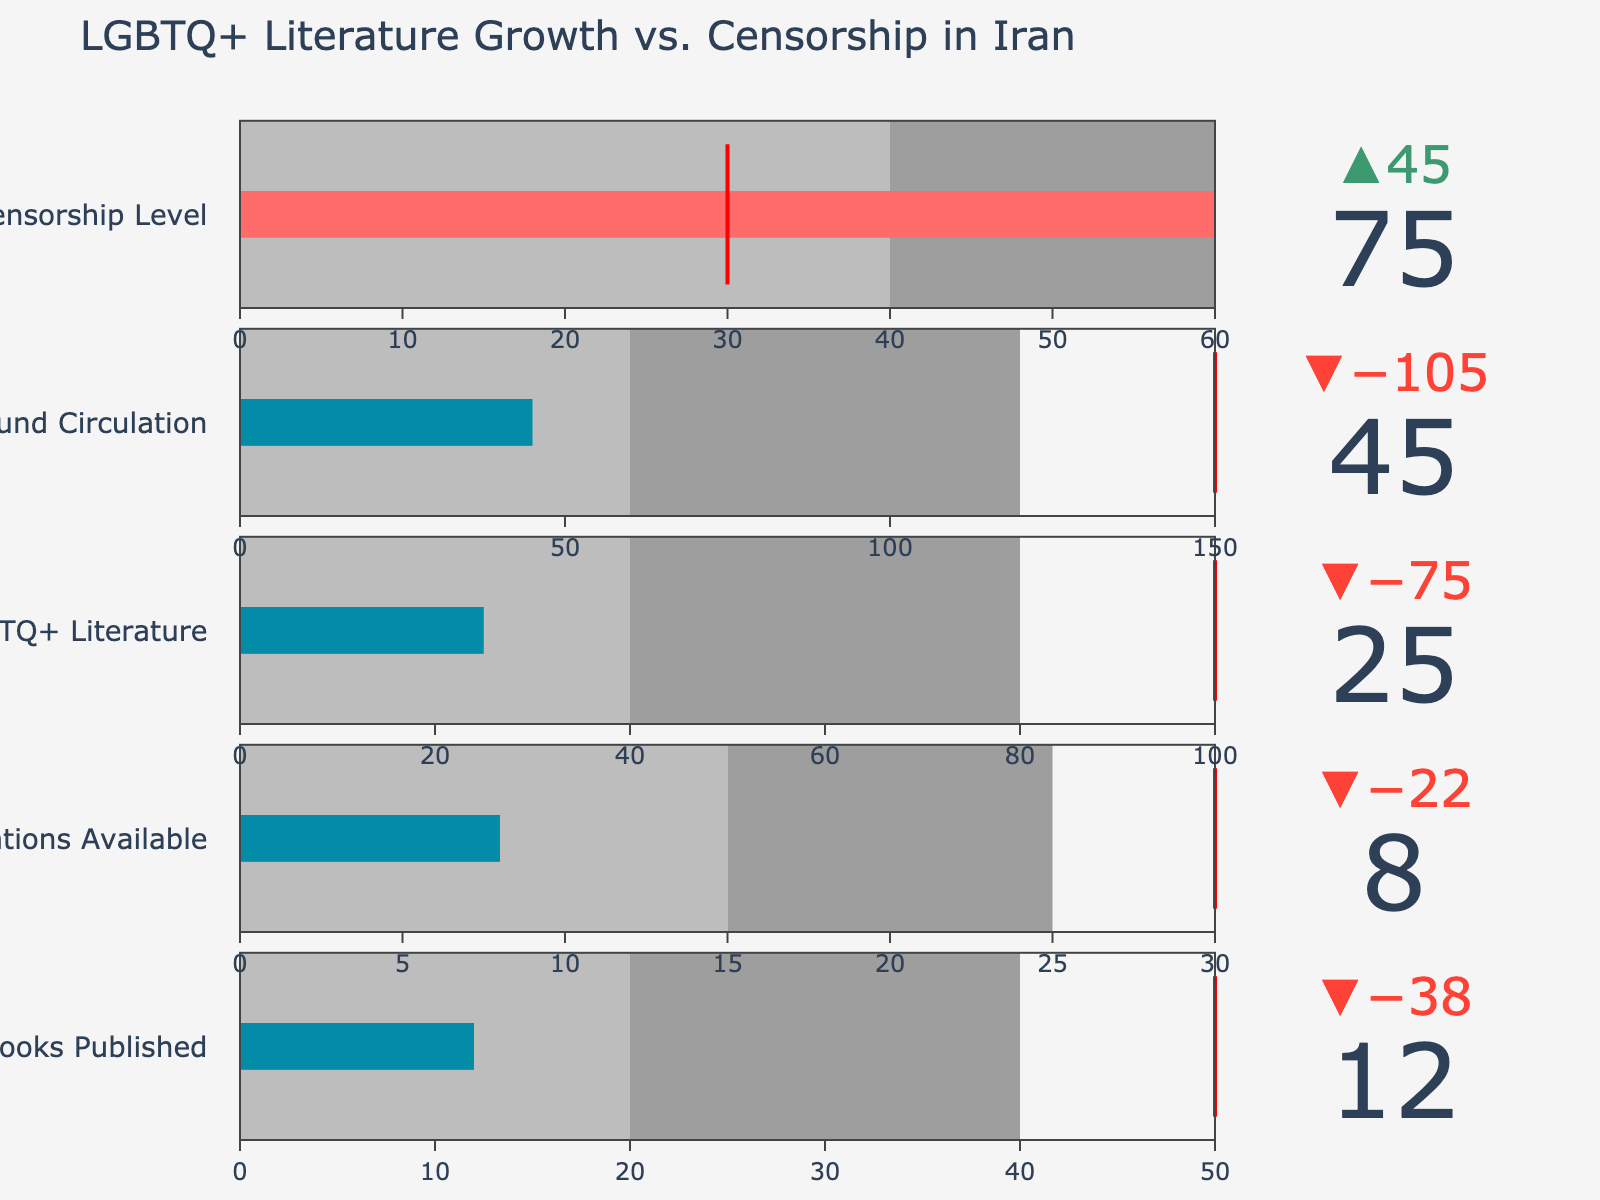How many LGBTQ+ books were published against the target? The “LGBTQ+ Books Published” category shows an actual value of 12 compared to a target of 50, as provided in the data values.
Answer: 12 What is the highest number in the “Underground Circulation” data point? The highest number for "Underground Circulation" can be found in the ranges or the actual values. The actual number is 45 and is against a target of 150.
Answer: 150 Is the government censorship level above its target? The actual censorship level is shown as 75 against its target of 30. Since 75 is greater than 30, it is above its target.
Answer: Yes By how much does the “Online LGBTQ+ Literature” fall short of its target? The actual value for "Online LGBTQ+ Literature" is 25, whereas the target is 100. To find how much it falls short, subtract the actual from the target: 100 - 25 = 75.
Answer: 75 Which category shows the smallest difference between actual and target values? Calculate the differences for each category: 
- LGBTQ+ Books Published: 50 - 12 = 38
- Translations Available: 30 - 8 = 22
- Online LGBTQ+ Literature: 100 - 25 = 75
- Underground Circulation: 150 - 45 = 105
- Government Censorship Level: 75 - 30 = 45 (actual is higher)
The smallest difference is 22 for "Translations Available."
Answer: Translations Available Which categories have their actual values higher than Range2? Compare the actual values with Range2 values for all categories:
- LGBTQ+ Books Published: 12 < 20
- Translations Available: 8 < 15
- Online LGBTQ+ Literature: 25 > 40
- Underground Circulation: 45 > 60
- Government Censorship Level: 75 > 40
Only "Government Censorship Level" and "Online LGBTQ+ Literature" have actual values higher than Range2.
Answer: Government Censorship Level, Online LGBTQ+ Literature For which categories does the actual value fall within Range1? Compare the actual values with Range1 values for all categories:
- LGBTQ+ Books Published: 0 ≤ 12 < 20
- Translations Available: 0 ≤ 8 < 15
- Online LGBTQ+ Literature: 25 is not within 0 to 40
- Underground Circulation: 45 is not within 0 to 60
- Government Censorship Level: 75 is not within 0 to 40
"LGBTQ+ Books Published" and "Translations Available" fall within Range1.
Answer: LGBTQ+ Books Published, Translations Available How does the actual value of “Government Censorship Level” compare to the ranges? The actual value for "Government Censorship Level" is 75. It is within the third range (40 to 60).
Answer: It is within the third range 